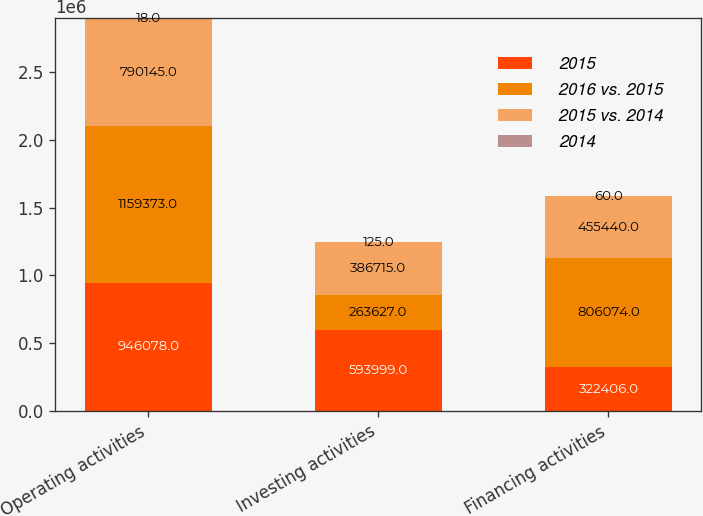<chart> <loc_0><loc_0><loc_500><loc_500><stacked_bar_chart><ecel><fcel>Operating activities<fcel>Investing activities<fcel>Financing activities<nl><fcel>2015<fcel>946078<fcel>593999<fcel>322406<nl><fcel>2016 vs. 2015<fcel>1.15937e+06<fcel>263627<fcel>806074<nl><fcel>2015 vs. 2014<fcel>790145<fcel>386715<fcel>455440<nl><fcel>2014<fcel>18<fcel>125<fcel>60<nl></chart> 